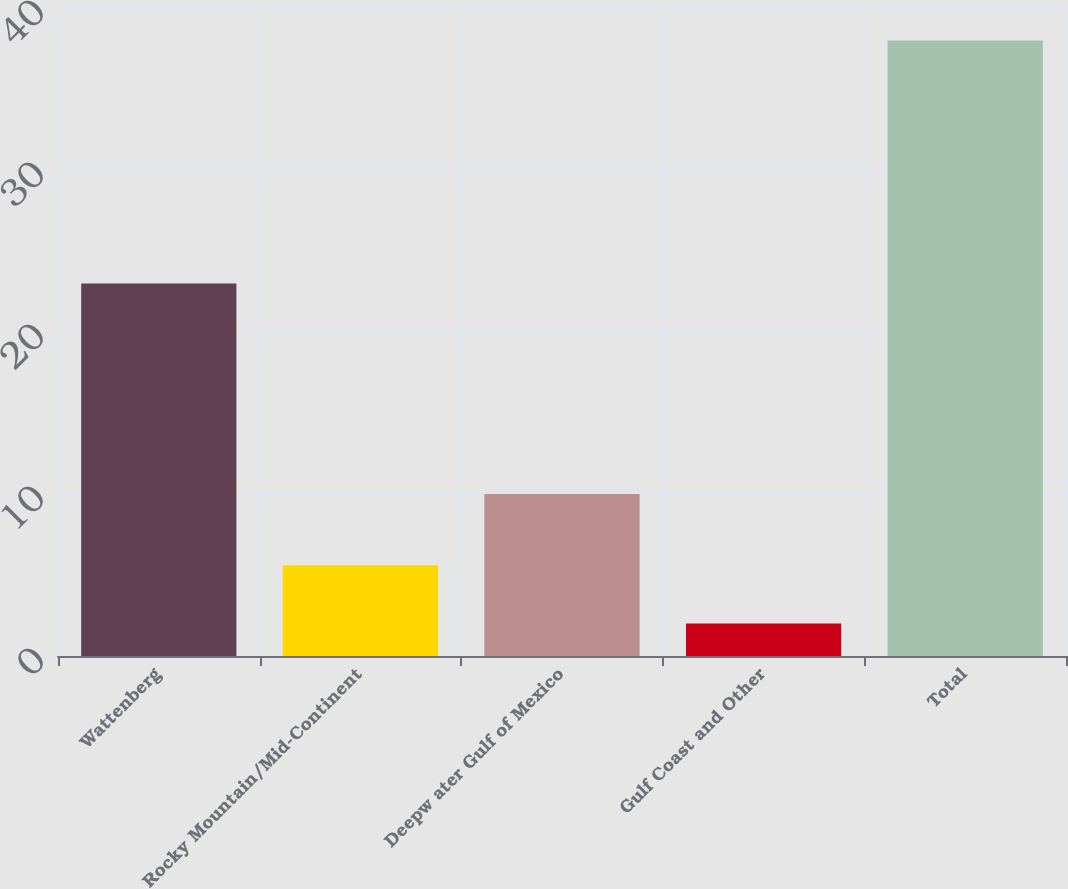Convert chart to OTSL. <chart><loc_0><loc_0><loc_500><loc_500><bar_chart><fcel>Wattenberg<fcel>Rocky Mountain/Mid-Continent<fcel>Deepw ater Gulf of Mexico<fcel>Gulf Coast and Other<fcel>Total<nl><fcel>23<fcel>5.6<fcel>10<fcel>2<fcel>38<nl></chart> 